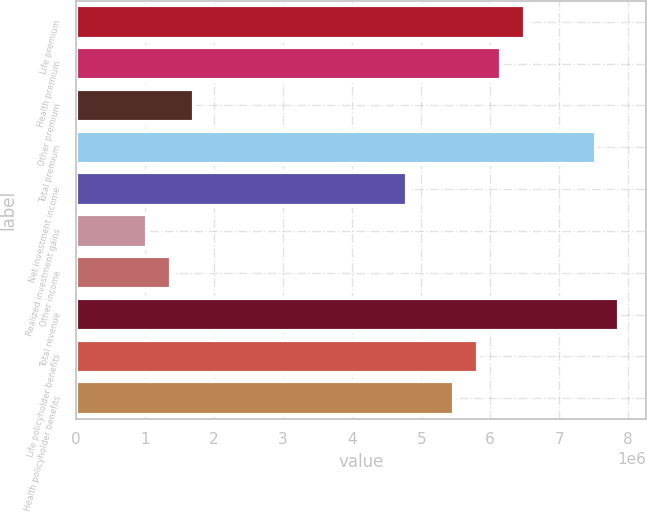<chart> <loc_0><loc_0><loc_500><loc_500><bar_chart><fcel>Life premium<fcel>Health premium<fcel>Other premium<fcel>Total premium<fcel>Net investment income<fcel>Realized investment gains<fcel>Other income<fcel>Total revenue<fcel>Life policyholder benefits<fcel>Health policyholder benefits<nl><fcel>6.50024e+06<fcel>6.15812e+06<fcel>1.71059e+06<fcel>7.52659e+06<fcel>4.78965e+06<fcel>1.02635e+06<fcel>1.36847e+06<fcel>7.86871e+06<fcel>5.816e+06<fcel>5.47388e+06<nl></chart> 